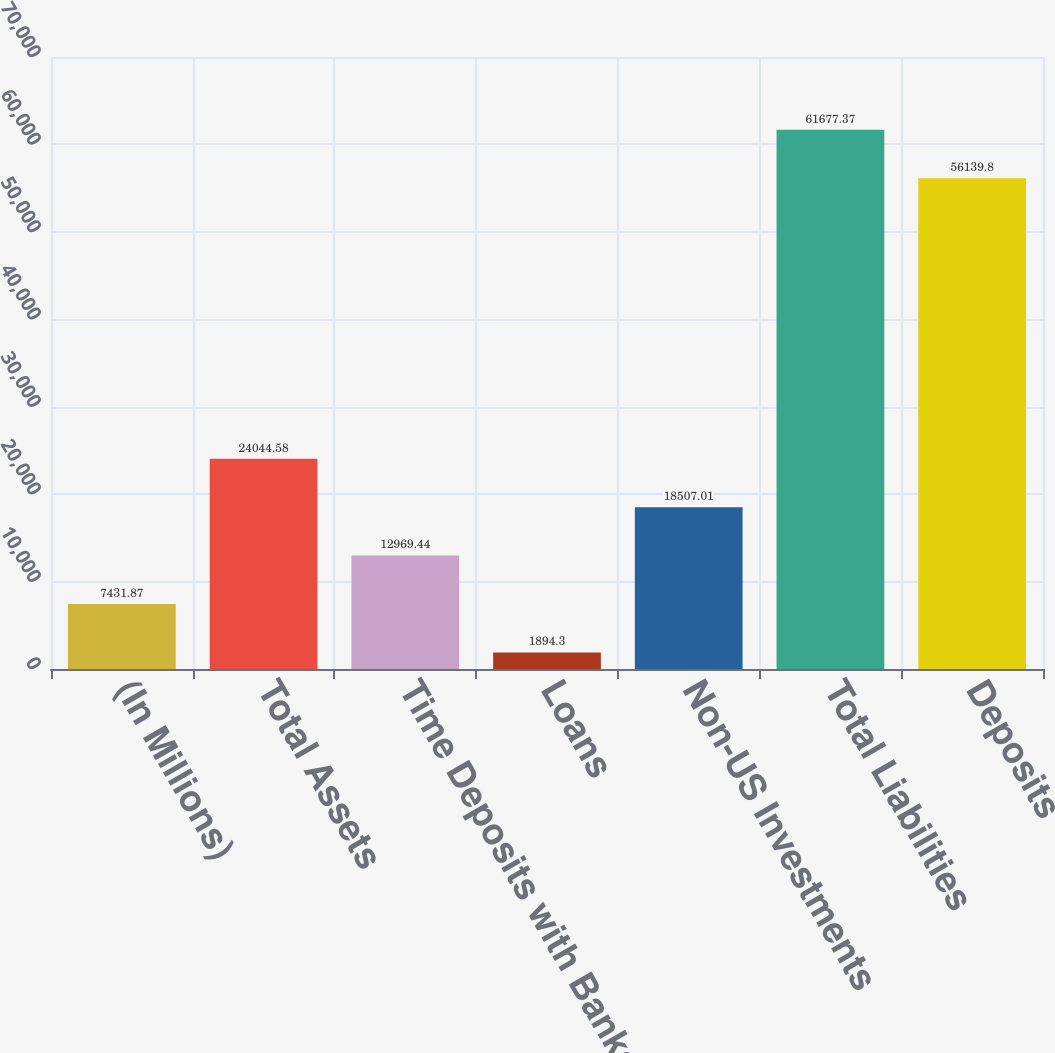Convert chart to OTSL. <chart><loc_0><loc_0><loc_500><loc_500><bar_chart><fcel>(In Millions)<fcel>Total Assets<fcel>Time Deposits with Banks<fcel>Loans<fcel>Non-US Investments<fcel>Total Liabilities<fcel>Deposits<nl><fcel>7431.87<fcel>24044.6<fcel>12969.4<fcel>1894.3<fcel>18507<fcel>61677.4<fcel>56139.8<nl></chart> 